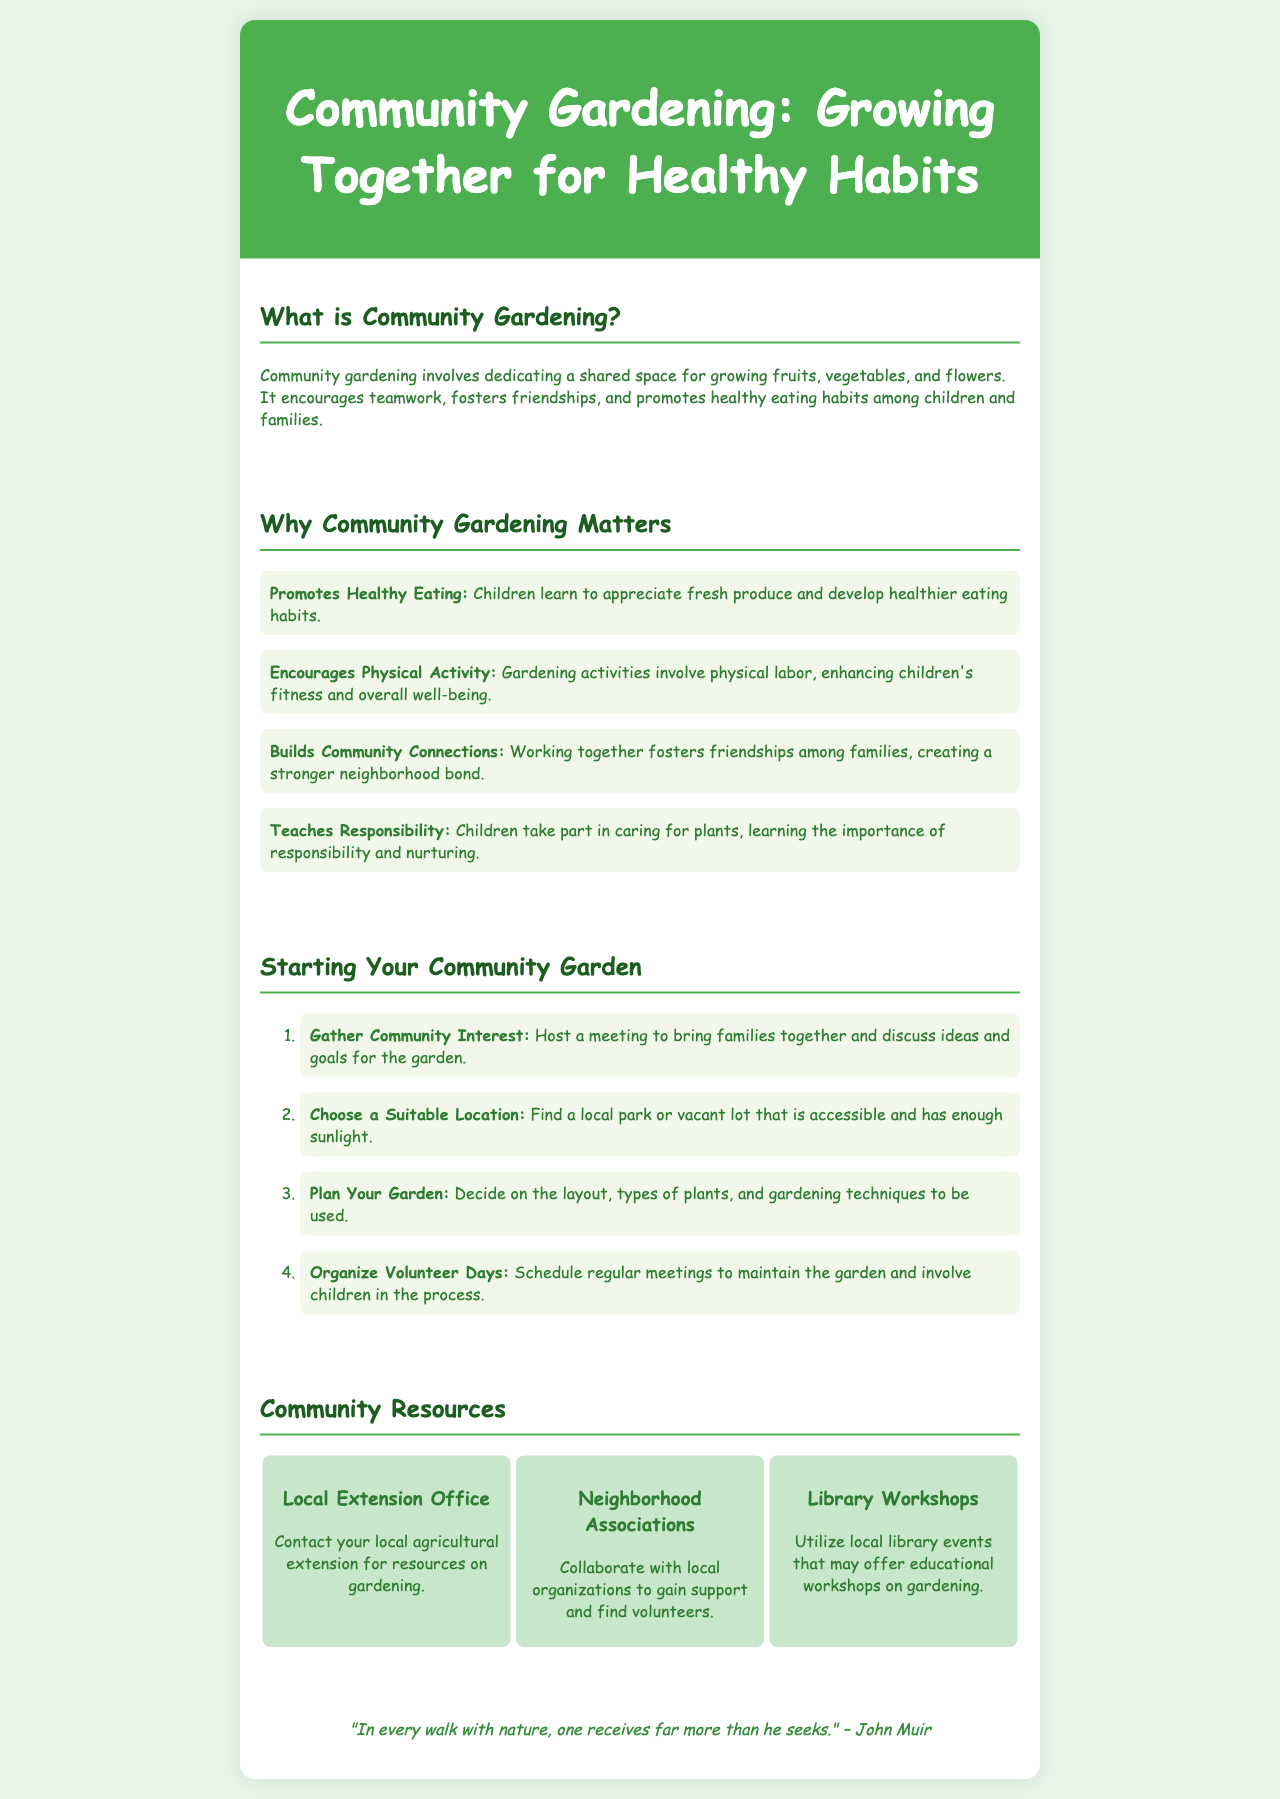What is Community Gardening? The document defines community gardening as dedicating a shared space for growing fruits, vegetables, and flowers, which encourages teamwork and promotes healthy eating habits.
Answer: A shared space for growing fruits, vegetables, and flowers What are the benefits of Community Gardening? The document lists four benefits including promoting healthy eating, encouraging physical activity, building community connections, and teaching responsibility.
Answer: Promotes Healthy Eating, Encourages Physical Activity, Builds Community Connections, Teaches Responsibility How many steps are in starting a Community Garden? The document outlines a total of four steps to start a community garden.
Answer: Four What should you do first to start a Community Garden? The first step mentioned in the document is to gather community interest.
Answer: Gather Community Interest What quote is included in the brochure? The document features a quote by John Muir regarding nature and the benefits of walking in it.
Answer: "In every walk with nature, one receives far more than he seeks." What type of local resource is suggested for gardening support? The document mentions the local extension office as a resource for gardening information.
Answer: Local Extension Office What organization's collaboration is encouraged in the document? The document suggests collaborating with neighborhood associations for support and volunteers.
Answer: Neighborhood Associations What is one activity included in organizing the community garden? One of the suggested activities is scheduling regular meetings to maintain the garden and involve children.
Answer: Organize Volunteer Days 